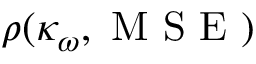Convert formula to latex. <formula><loc_0><loc_0><loc_500><loc_500>\rho ( \kappa _ { \omega } , M S E )</formula> 